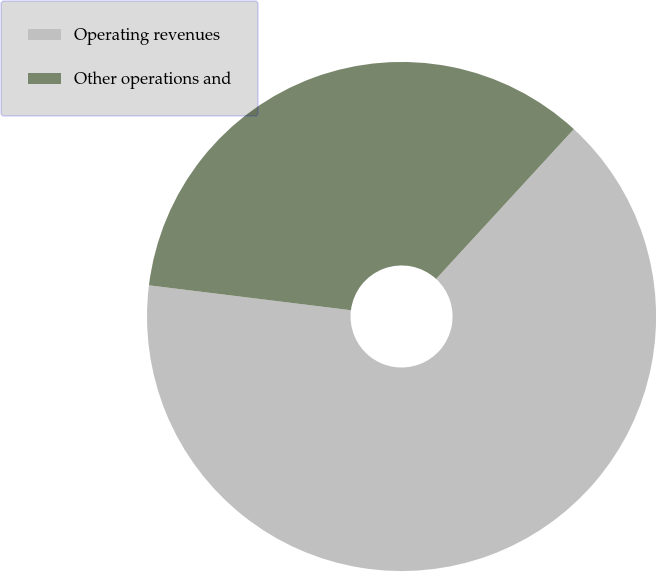Convert chart. <chart><loc_0><loc_0><loc_500><loc_500><pie_chart><fcel>Operating revenues<fcel>Other operations and<nl><fcel>65.12%<fcel>34.88%<nl></chart> 